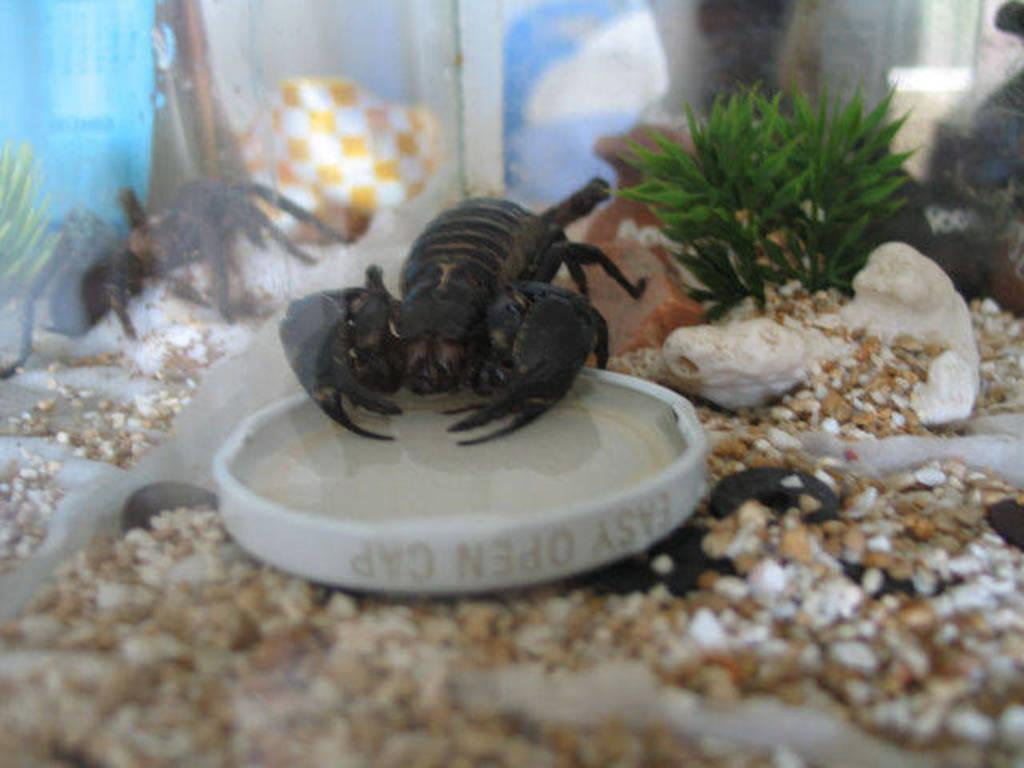What type of animal can be seen in the image? There is a scorpion in the image. What other objects are present in the image? There are capstones and shells in the image. Is there any vegetation in the image? Yes, there is a plant in the image. Where are all these objects located? All of these objects are in an aquarium. How does the scorpion show respect to the geese in the image? There are no geese present in the image, so the scorpion cannot show respect to them. 